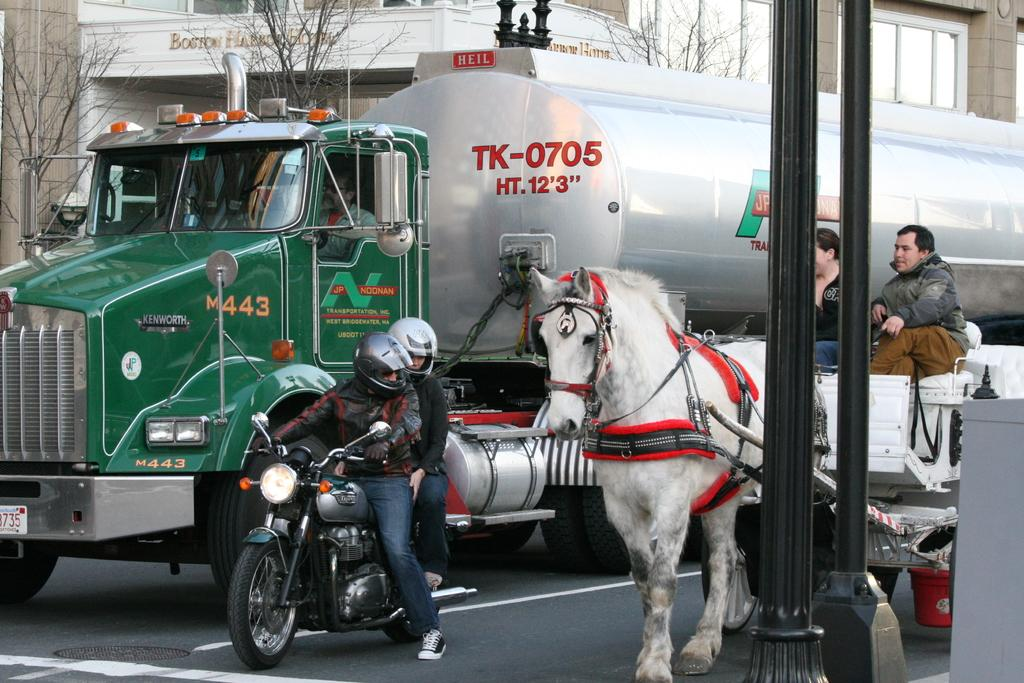What type of vehicle is present in the image? There is a truck with a tanker in the image. What animal can be seen in the image? There is a horse in the image. How many people are riding a motorbike in the image? There are two persons riding a motorbike in the image. What can be seen in the background of the image? There are trees, buildings, and windows visible in the background of the image. What type of grain is being transported by the truck in the image? There is no indication of the contents of the tanker in the image, so it cannot be determined what type of grain, if any, any, is being transported. What street is the motorbike riding on in the image? The image does not show a street or any indication of a specific location, so it cannot be determined which street the motorbike is riding on. 